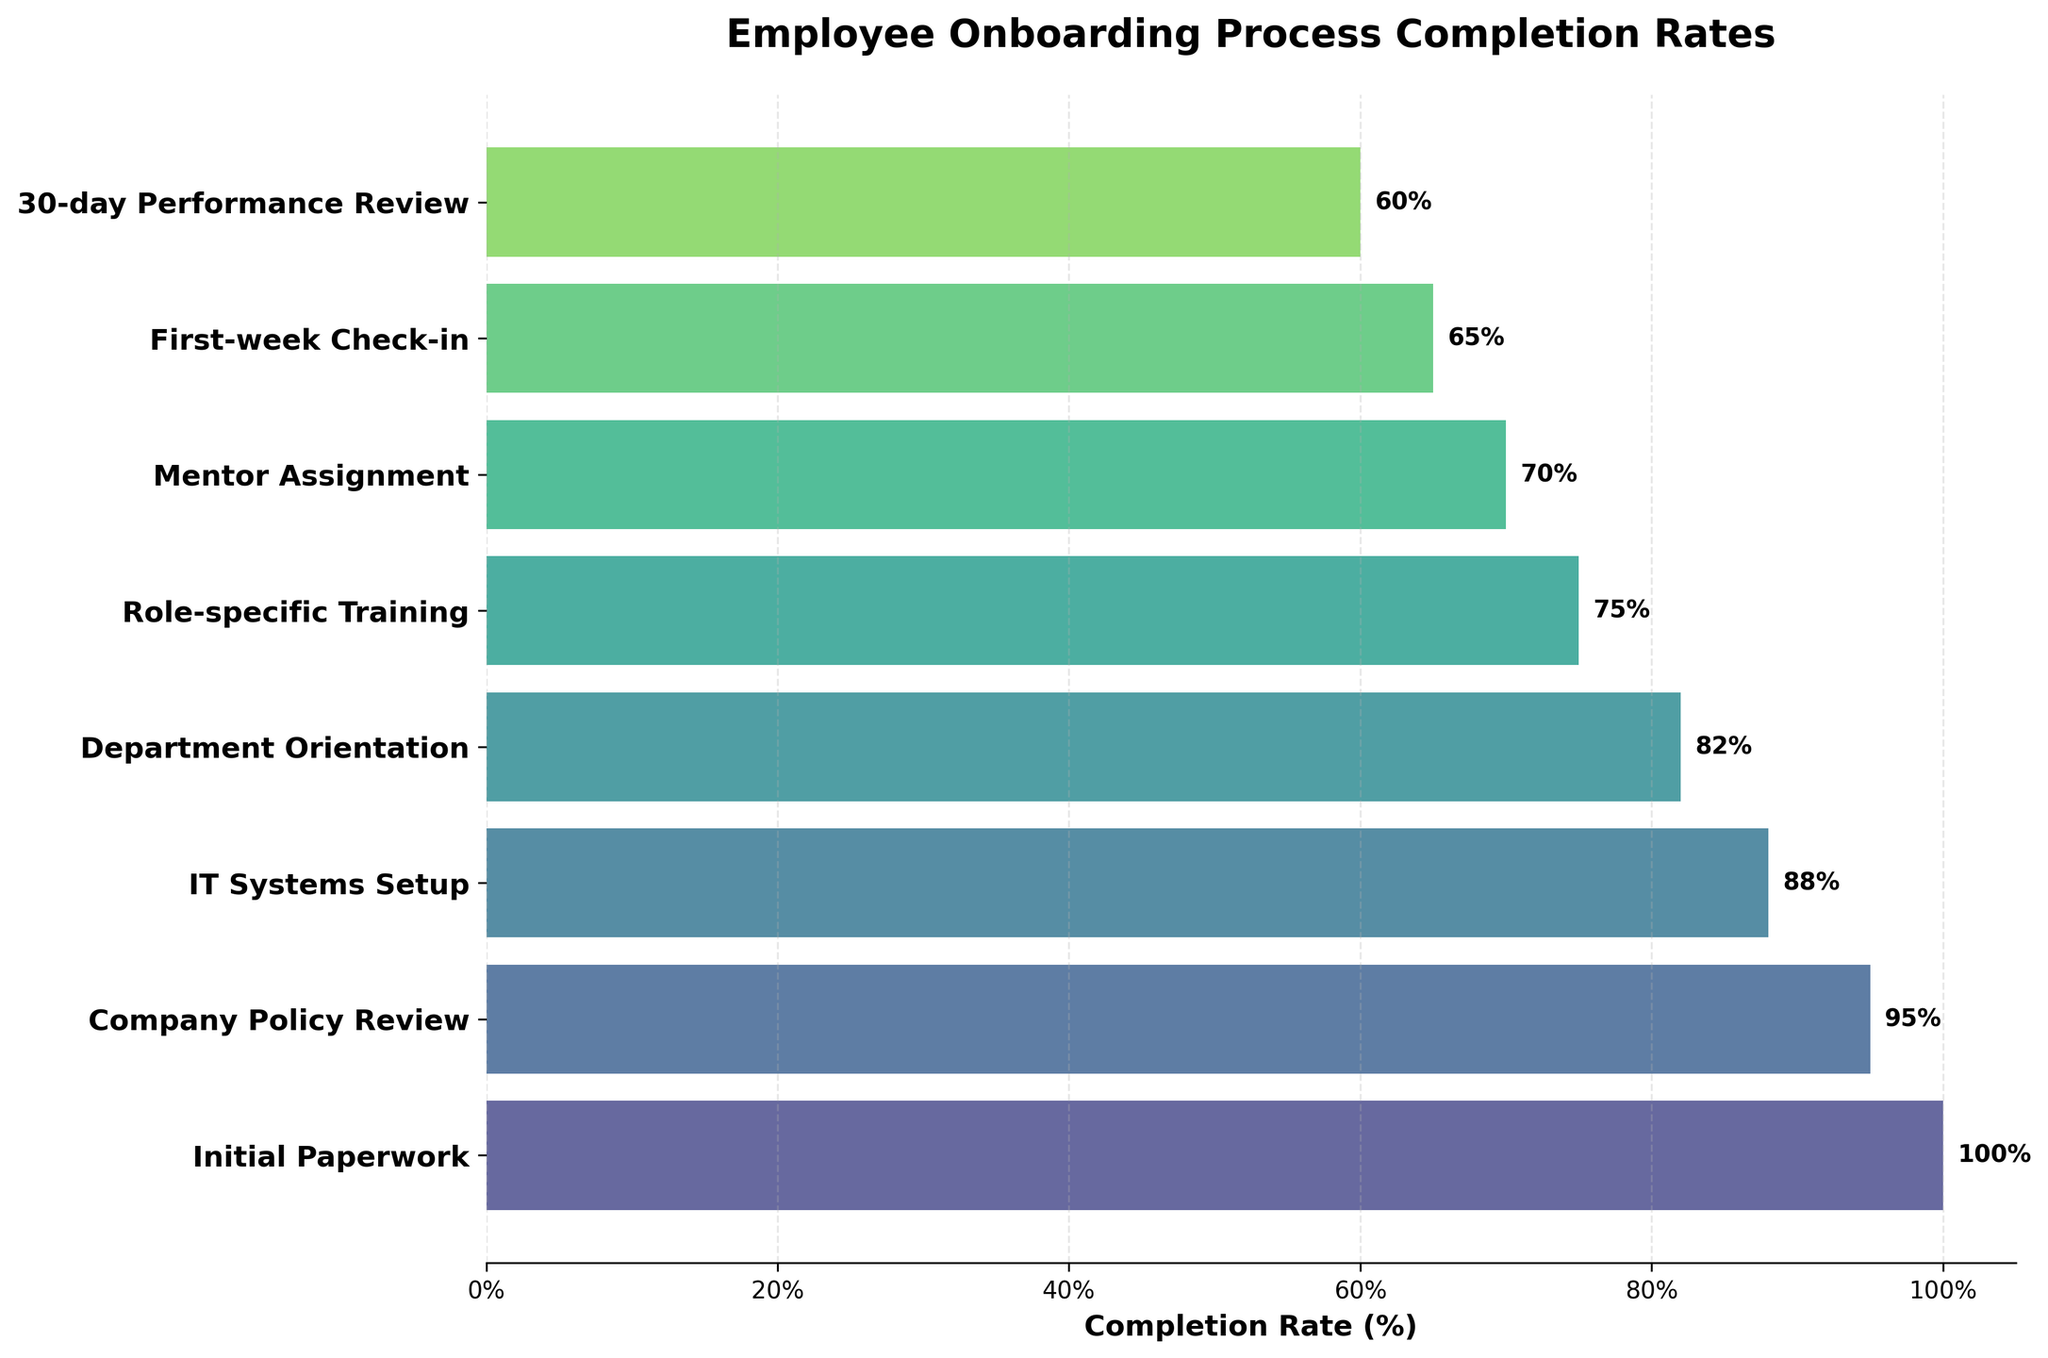What is the title of the funnel chart? The title is located at the top center of the funnel chart. It clearly states the subject of the chart.
Answer: Employee Onboarding Process Completion Rates What is the highest completion rate stage, and what is its percentage? The stage with the highest completion rate is at the top of the funnel, and we can see the percentage label next to it.
Answer: Initial Paperwork, 100% Which stage has the lowest completion rate and what is the percentage? The stage with the lowest completion rate is at the bottom of the funnel, and the percentage label is next to it.
Answer: 30-day Performance Review, 60% What is the completion rate difference between IT Systems Setup and First-week Check-in? Identify the completion rates for IT Systems Setup and First-week Check-in from the chart and then subtract the latter from the former.
Answer: 88% - 65% = 23% How many stages have completion rates above 70%? Count the stages from the chart that have labels showing completion rates above 70%.
Answer: 5 stages Which stages have a completion rate between 80% and 90%? Identify and list the stages whose completion rates fall in the range 80%-90% as displayed in the funnel chart.
Answer: IT Systems Setup, Department Orientation Compare the completion rates of Company Policy Review and Mentor Assignment. Which one is higher and by how much? From the chart, find and compare the completion rates of Company Policy Review and Mentor Assignment. Subtract the smaller percentage from the larger one.
Answer: Company Policy Review is higher by 25% (95% - 70%) What is the average completion rate of all stages? Add up all completion rates from the chart and divide by the number of stages (8).
Answer: (100% + 95% + 88% + 82% + 75% + 70% + 65% + 60%) / 8 = 79.375% How much do completion rates drop from Initial Paperwork to Role-specific Training? Identify the completion rates of the respective stages and calculate the difference by subtracting Role-specific Training's rate from Initial Paperwork's rate.
Answer: 100% - 75% = 25% Evaluate the drop in completion rates from Mentor Assignment to 30-day Performance Review. What percentage does it represent of the Mentor Assignment rate? Calculate the difference between the two rates and then find what percentage this difference (drop) is of the Mentor Assignment rate.
Answer: (70% - 60%) / 70% * 100 = 14.29% 